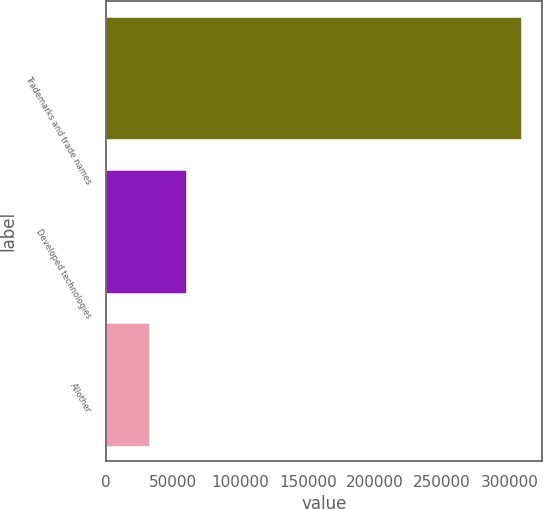Convert chart. <chart><loc_0><loc_0><loc_500><loc_500><bar_chart><fcel>Trademarks and trade names<fcel>Developed technologies<fcel>Allother<nl><fcel>308968<fcel>59591.5<fcel>31883<nl></chart> 